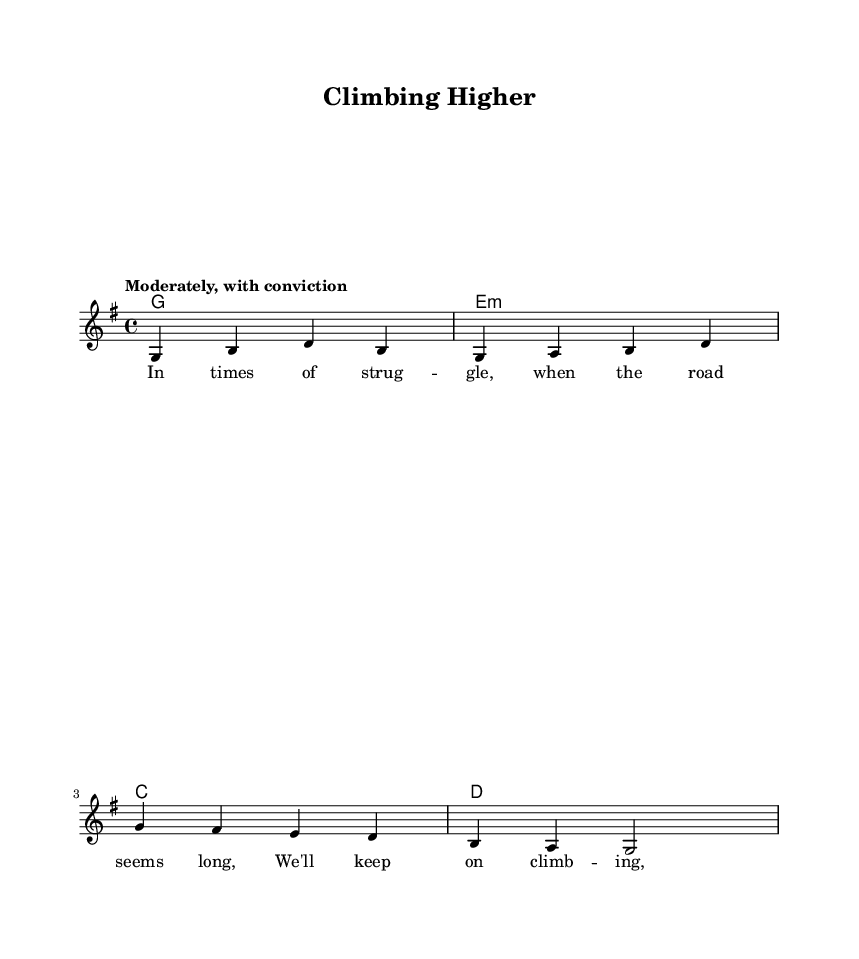What is the key signature of this music? The key signature is indicated at the beginning of the staff and shows one sharp (F#), characteristic of G major.
Answer: G major What is the time signature of this piece? The time signature is located at the beginning of the piece and is shown as 4/4, which means four beats per measure.
Answer: 4/4 What is the tempo marking for this hymn? The tempo marking is specified at the beginning of the score and states "Moderately, with conviction."
Answer: Moderately, with conviction How many measures are in the melody? By counting the measures in the melody section, there are four measures in total.
Answer: Four What is the lyrical theme of this hymn? The lyrics emphasize perseverance and strength in adversity, which is a common theme in gospel hymns about overcoming struggles.
Answer: Perseverance What is the chord progression used in the harmonies? The chord sequence consists of G major, E minor, C major, and D major, reflecting a typical gospel music progression.
Answer: G - E minor - C - D How does the structure of this hymn reflect its religious context? The structure supports the theme of hope and faith, common in gospel hymns, using repetitive lyrical phrases and a strong melody to enhance the message.
Answer: Hope and faith 